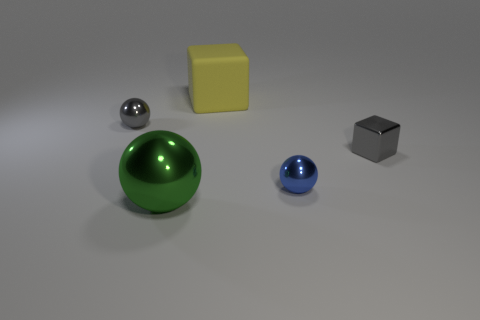Subtract all tiny blue balls. How many balls are left? 2 Subtract all yellow blocks. How many blocks are left? 1 Subtract all blocks. How many objects are left? 3 Subtract 2 cubes. How many cubes are left? 0 Subtract all brown spheres. Subtract all purple blocks. How many spheres are left? 3 Subtract all red cubes. How many gray balls are left? 1 Subtract all yellow balls. Subtract all small blue metallic balls. How many objects are left? 4 Add 5 gray things. How many gray things are left? 7 Add 1 large yellow rubber things. How many large yellow rubber things exist? 2 Add 2 large yellow cubes. How many objects exist? 7 